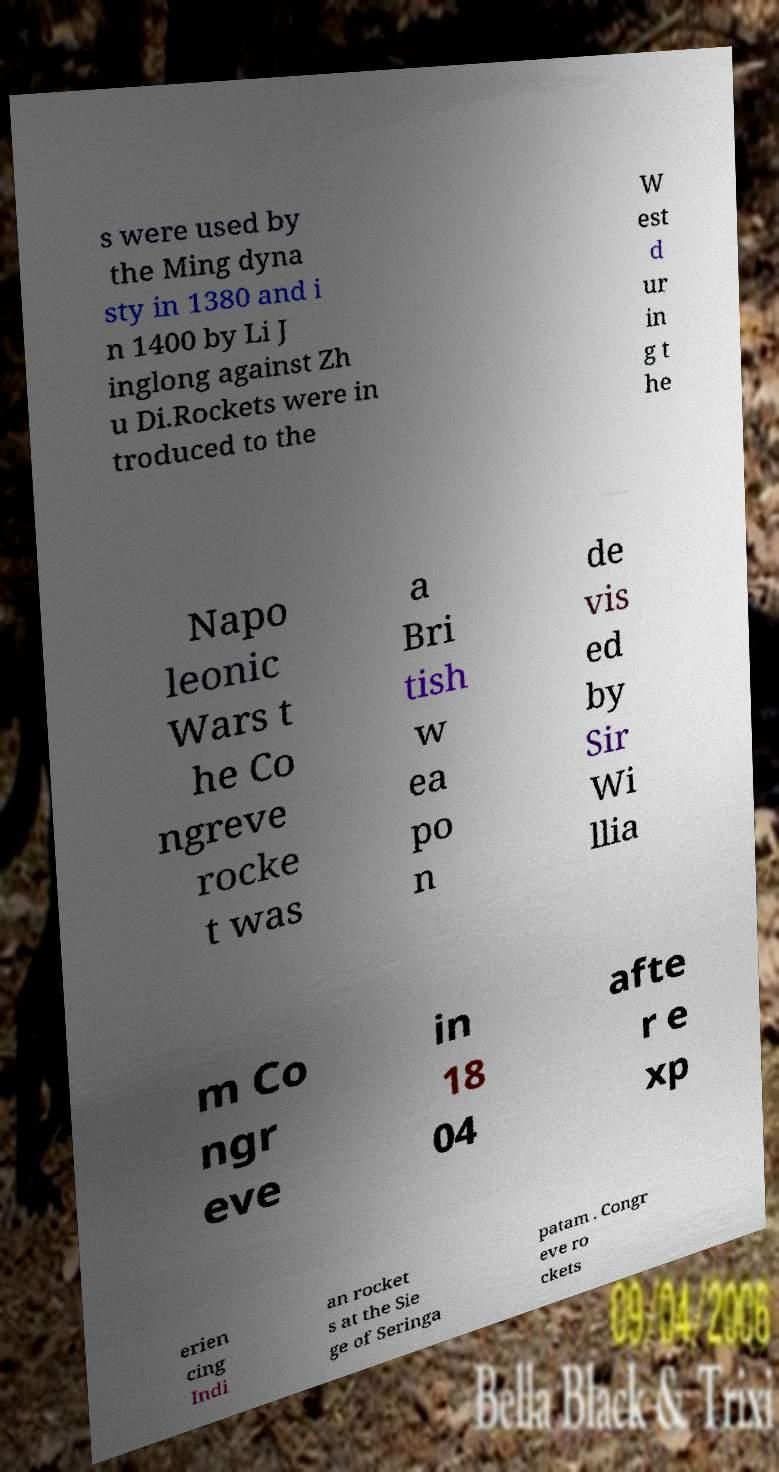Can you read and provide the text displayed in the image?This photo seems to have some interesting text. Can you extract and type it out for me? s were used by the Ming dyna sty in 1380 and i n 1400 by Li J inglong against Zh u Di.Rockets were in troduced to the W est d ur in g t he Napo leonic Wars t he Co ngreve rocke t was a Bri tish w ea po n de vis ed by Sir Wi llia m Co ngr eve in 18 04 afte r e xp erien cing Indi an rocket s at the Sie ge of Seringa patam . Congr eve ro ckets 